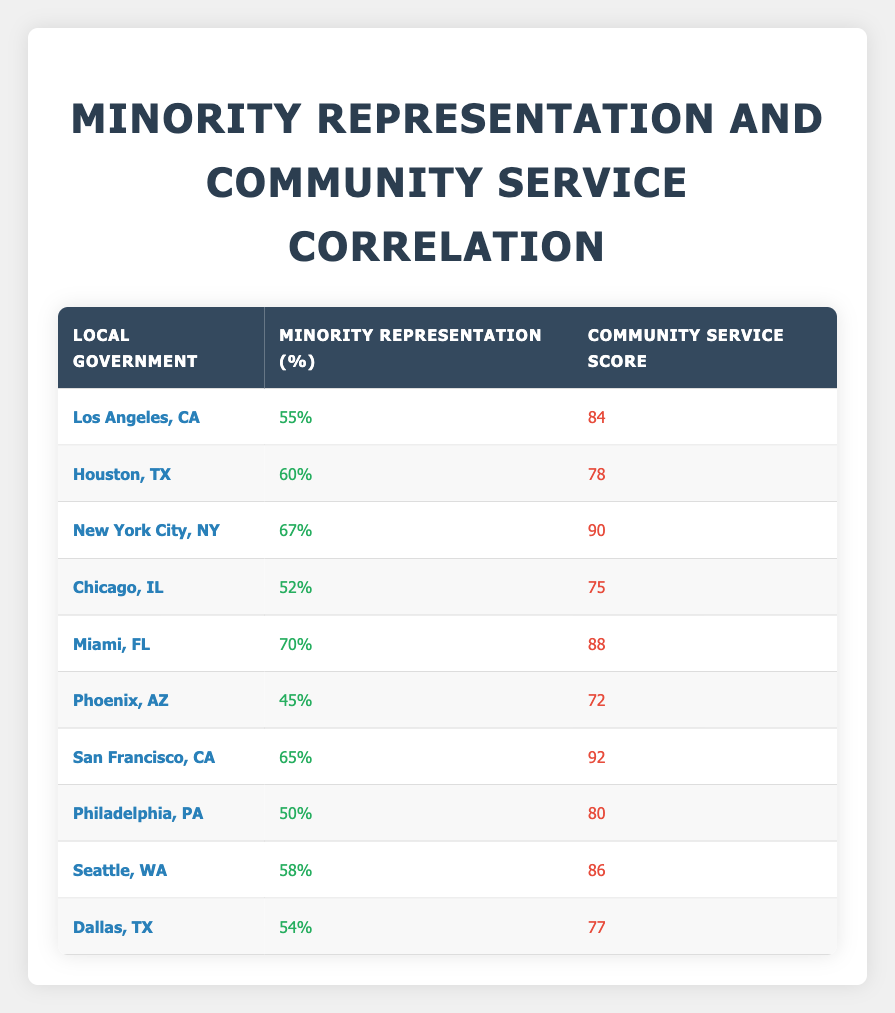What is the community service score for Miami, FL? The table shows that the community service score for Miami, FL is listed under the "Community Service Score" column, which states 88.
Answer: 88 Which local government has the highest percentage of minority representation? By checking the "Percentage Minority Representation" column, we see that New York City, NY has the highest percentage at 67%.
Answer: New York City, NY How many local governments have a community service score greater than 80? The scores greater than 80 are for New York City (90), Miami (88), San Francisco (92), and Seattle (86). This gives us a total of 4 local governments.
Answer: 4 Is the percentage of minority representation in Houston, TX greater than that in Chicago, IL? The table indicates that Houston, TX has a minority representation of 60% while Chicago, IL has 52%. Therefore, 60% is greater than 52%.
Answer: Yes What is the average community service score of local governments with more than 60% minority representation? We will first identify the local governments with greater than 60% representation: New York City (90), Miami (88), and San Francisco (92). The scores sum up as 90 + 88 + 92 = 270. There are 3 points, so the average is 270 / 3 = 90.
Answer: 90 Which local government has the lowest community service score, and what is that score? By examining the "Community Service Score" column, we can see that Phoenix, AZ has the lowest score at 72.
Answer: Phoenix, AZ, 72 What is the difference in community service scores between Los Angeles, CA and Dallas, TX? The score for Los Angeles, CA is 84 and for Dallas, TX is 77. The difference is calculated as 84 - 77 = 7.
Answer: 7 How many local governments have a minority representation percentage less than 50%? By scanning the "Percentage Minority Representation" column, we see that no local government has an under 50% while Phoenix, AZ is the lowest at 45%. Thus, there are none below 50%.
Answer: 0 